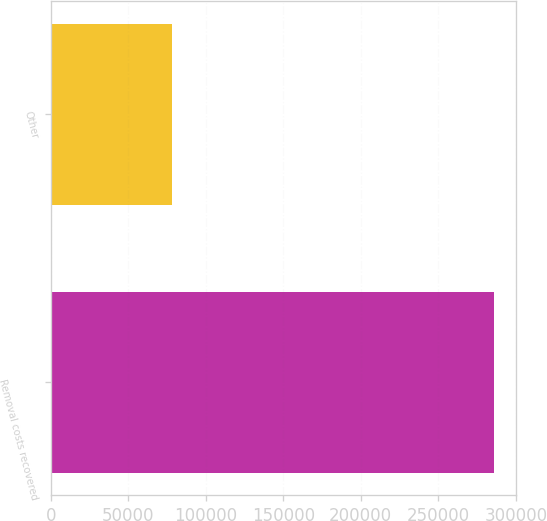Convert chart to OTSL. <chart><loc_0><loc_0><loc_500><loc_500><bar_chart><fcel>Removal costs recovered<fcel>Other<nl><fcel>285901<fcel>78280<nl></chart> 